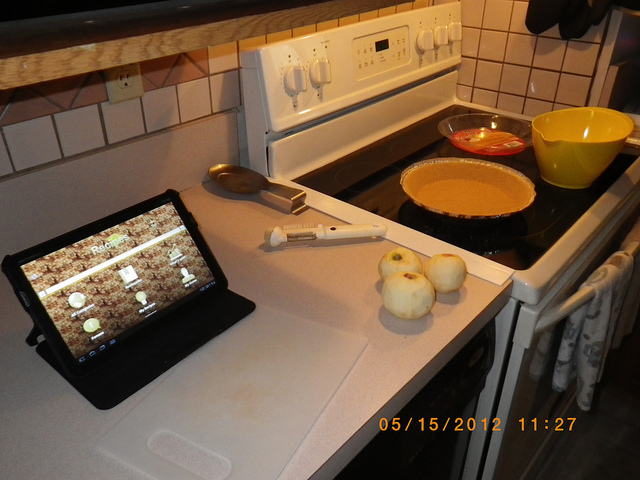<image>What brand is the oven? It is ambiguous what brand the oven is. It could be Kenmore, Frigidaire, or other brands. What brand is the oven? I don't know the brand of the oven. It can be Kenmore, Amama, GE, Samsung, Frigidaire, Whirlpool or unknown. 